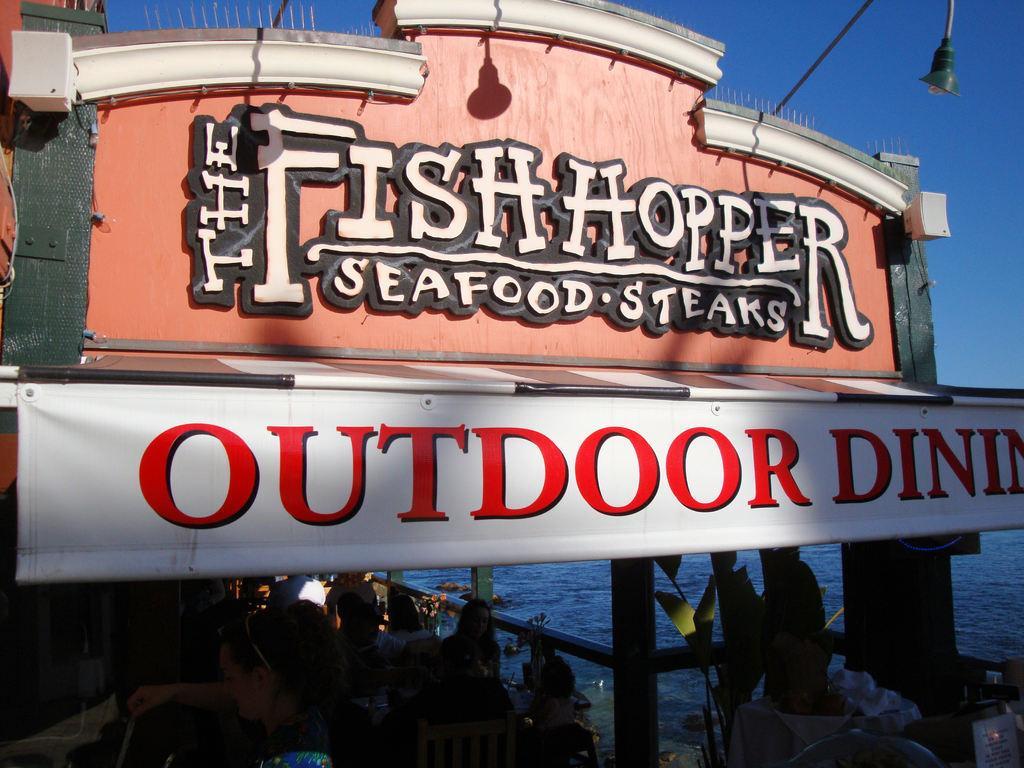Can you describe this image briefly? In this picture we can see arch on which we can see some words, down we can see banner and we can see few people are walking down. 